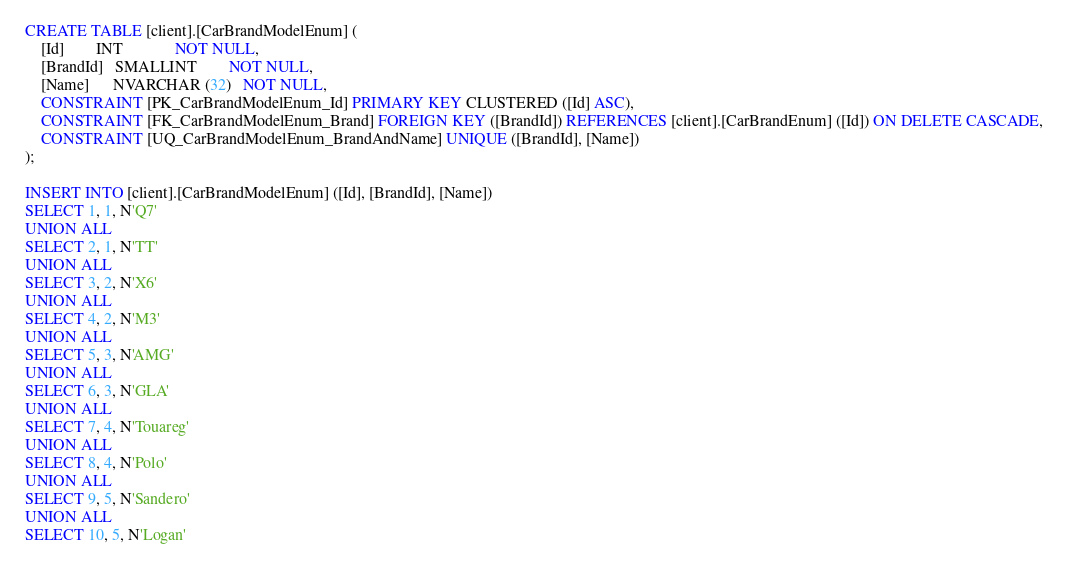Convert code to text. <code><loc_0><loc_0><loc_500><loc_500><_SQL_>CREATE TABLE [client].[CarBrandModelEnum] (
    [Id]        INT             NOT NULL,
    [BrandId]   SMALLINT        NOT NULL,
    [Name]      NVARCHAR (32)   NOT NULL,
    CONSTRAINT [PK_CarBrandModelEnum_Id] PRIMARY KEY CLUSTERED ([Id] ASC),
    CONSTRAINT [FK_CarBrandModelEnum_Brand] FOREIGN KEY ([BrandId]) REFERENCES [client].[CarBrandEnum] ([Id]) ON DELETE CASCADE,
    CONSTRAINT [UQ_CarBrandModelEnum_BrandAndName] UNIQUE ([BrandId], [Name])
);

INSERT INTO [client].[CarBrandModelEnum] ([Id], [BrandId], [Name])
SELECT 1, 1, N'Q7'
UNION ALL
SELECT 2, 1, N'TT'
UNION ALL
SELECT 3, 2, N'X6'
UNION ALL
SELECT 4, 2, N'M3'
UNION ALL
SELECT 5, 3, N'AMG'
UNION ALL
SELECT 6, 3, N'GLA'
UNION ALL
SELECT 7, 4, N'Touareg'
UNION ALL
SELECT 8, 4, N'Polo'
UNION ALL
SELECT 9, 5, N'Sandero'
UNION ALL
SELECT 10, 5, N'Logan'</code> 